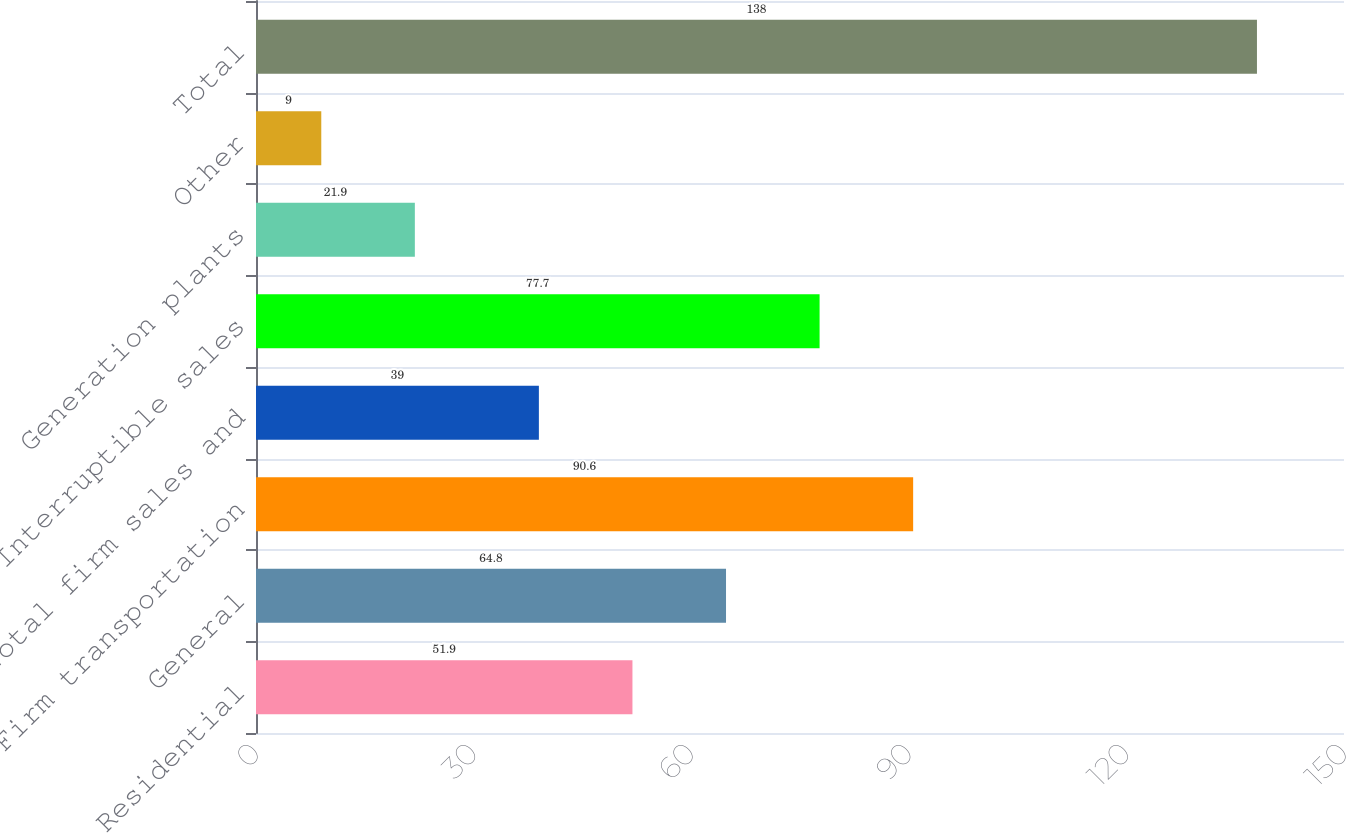<chart> <loc_0><loc_0><loc_500><loc_500><bar_chart><fcel>Residential<fcel>General<fcel>Firm transportation<fcel>Total firm sales and<fcel>Interruptible sales<fcel>Generation plants<fcel>Other<fcel>Total<nl><fcel>51.9<fcel>64.8<fcel>90.6<fcel>39<fcel>77.7<fcel>21.9<fcel>9<fcel>138<nl></chart> 